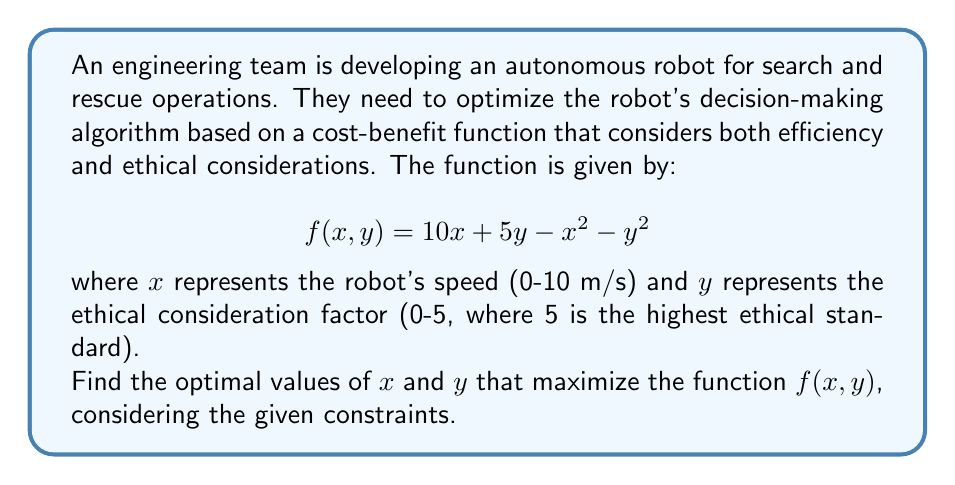Provide a solution to this math problem. To find the optimal values of $x$ and $y$ that maximize the function $f(x, y)$, we need to follow these steps:

1. Find the partial derivatives of $f(x, y)$ with respect to $x$ and $y$:
   $$\frac{\partial f}{\partial x} = 10 - 2x$$
   $$\frac{\partial f}{\partial y} = 5 - 2y$$

2. Set both partial derivatives to zero and solve for $x$ and $y$:
   $$10 - 2x = 0 \Rightarrow x = 5$$
   $$5 - 2y = 0 \Rightarrow y = 2.5$$

3. Check if the critical point $(5, 2.5)$ is within the given constraints:
   $x \in [0, 10]$ and $y \in [0, 5]$
   The point $(5, 2.5)$ satisfies both constraints.

4. Verify that this critical point is indeed a maximum by checking the second partial derivatives:
   $$\frac{\partial^2 f}{\partial x^2} = -2$$
   $$\frac{\partial^2 f}{\partial y^2} = -2$$
   $$\frac{\partial^2 f}{\partial x \partial y} = 0$$

   The Hessian matrix is:
   $$H = \begin{bmatrix} -2 & 0 \\ 0 & -2 \end{bmatrix}$$

   Since both second partial derivatives are negative and the determinant of the Hessian is positive, the critical point is a local maximum.

5. Therefore, the optimal values that maximize the function are $x = 5$ and $y = 2.5$.

These values suggest that the optimal balance between speed and ethical considerations for the autonomous robot is achieved at a speed of 5 m/s and an ethical consideration factor of 2.5.
Answer: $x = 5$, $y = 2.5$ 